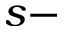Convert formula to latex. <formula><loc_0><loc_0><loc_500><loc_500>s -</formula> 